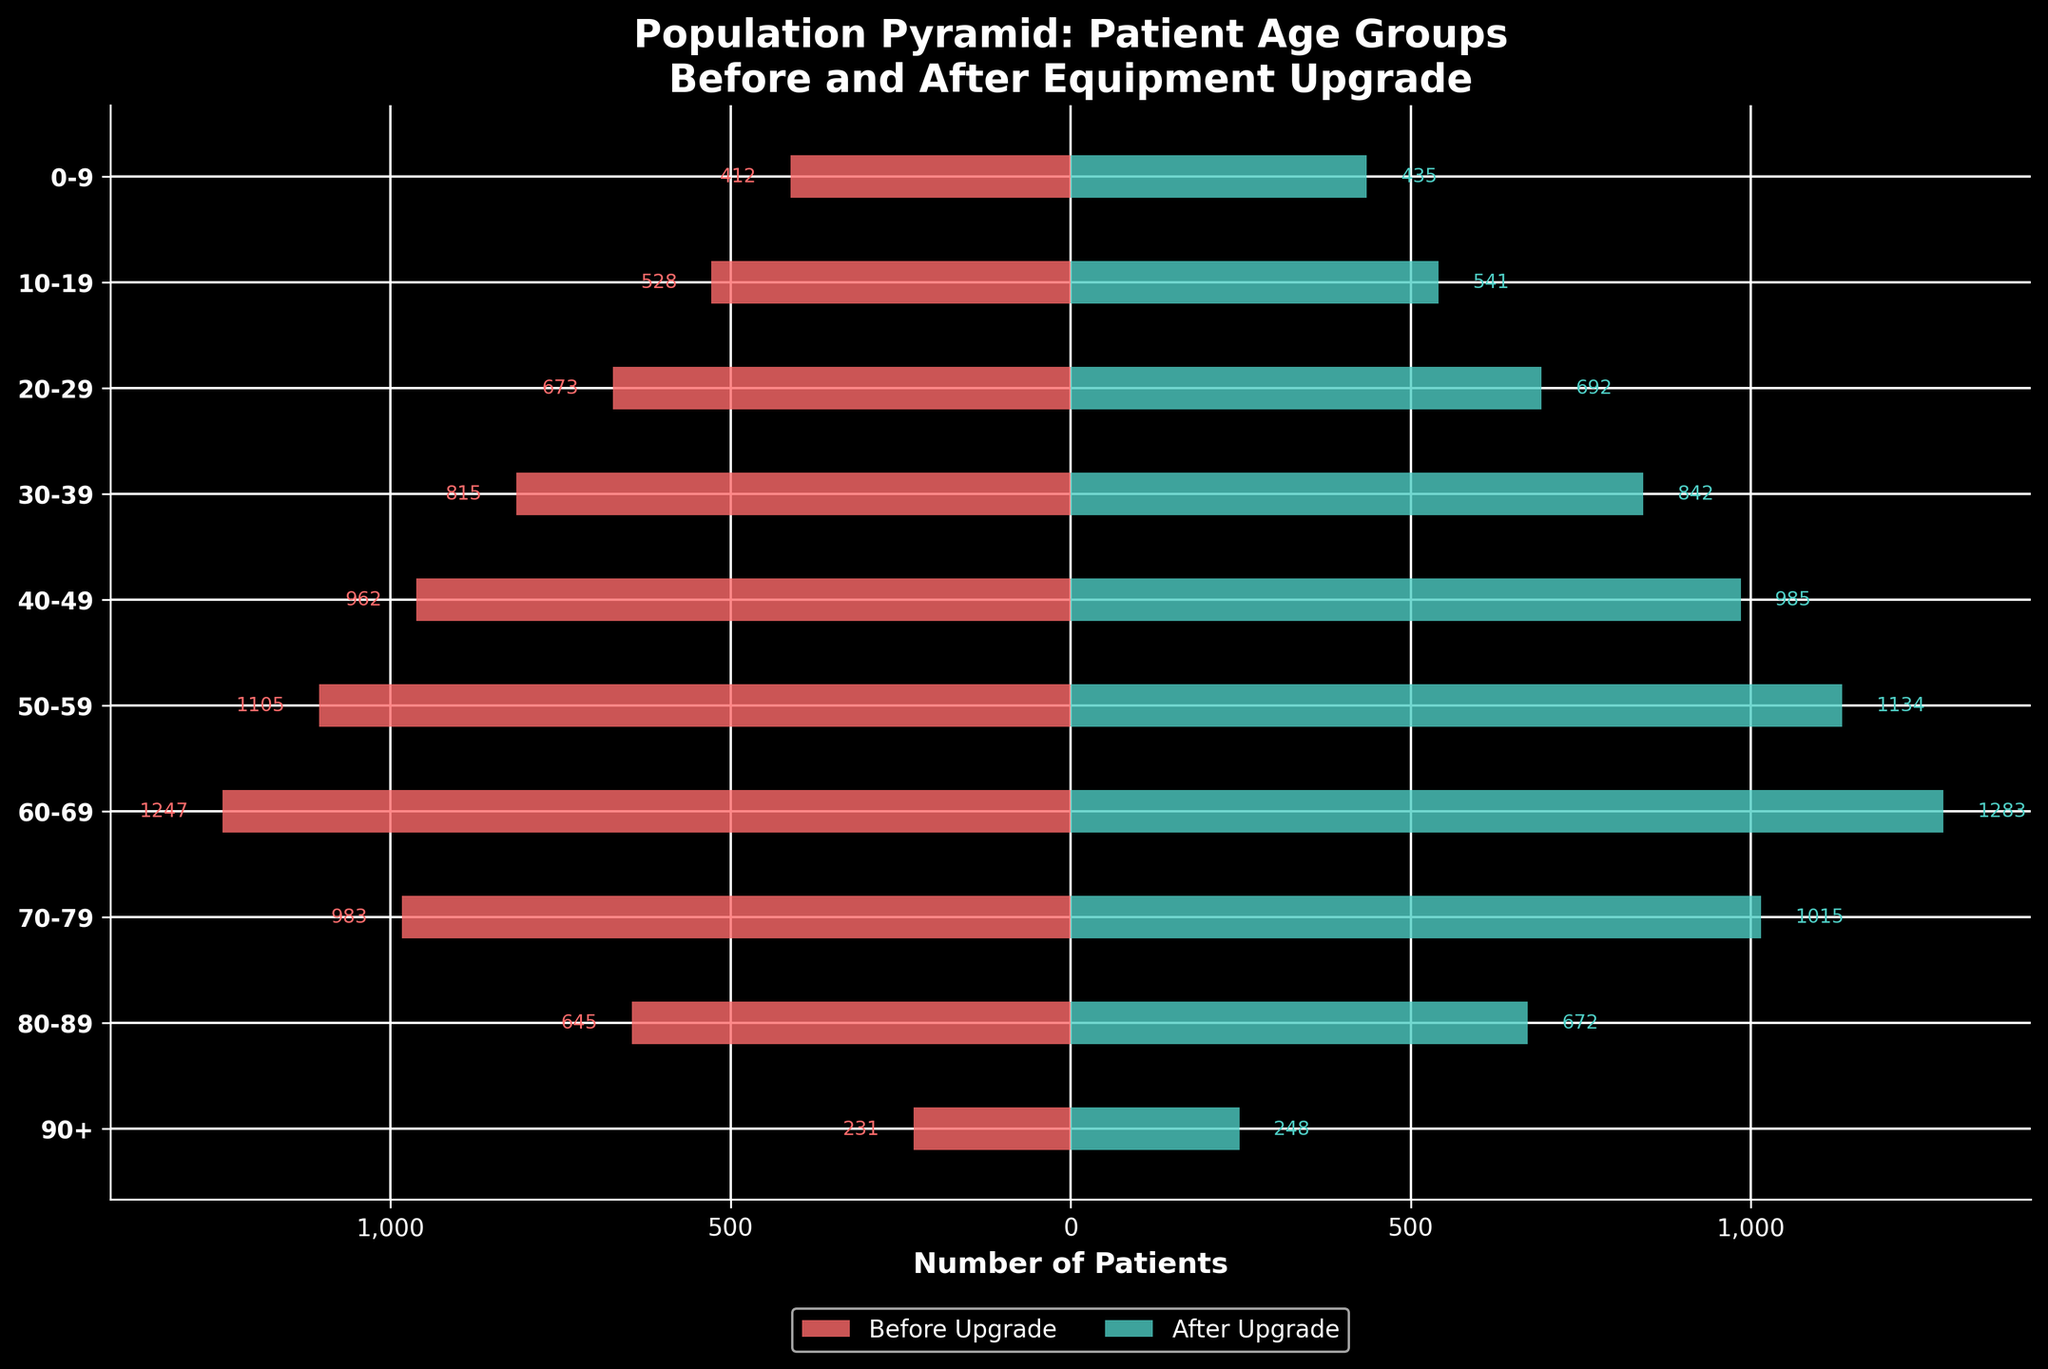What is the title of the figure? The title of the figure is usually shown at the top and provides a brief summary of what the figure represents.
Answer: Population Pyramid: Patient Age Groups Before and After Equipment Upgrade What are the age groups represented on the y-axis? The y-axis shows different age groups which are labeled clearly. Observing these age groups helps in understanding the distribution of patients.
Answer: 0-9, 10-19, 20-29, 30-39, 40-49, 50-59, 60-69, 70-79, 80-89, 90+ Which age group saw the largest increase in the number of patients after the upgrade? By comparing the number of patients before and after the upgrade for each age group, the one with the highest difference represents the largest increase. From the figure, each group's values can be compared visually.
Answer: 60-69 What is the number of patients in the age group 50-59 before and after the upgrade? The figure shows two bars representing the patient numbers before and after the upgrade for each age group, with the exact values labeled on the horizontal bars.
Answer: Before: 1105, After: 1134 How many more patients are there in the 90+ age group after the upgrade compared to before? This involves finding the difference between the number of patients after and before the upgrade for the 90+ age group. From the figure, we read the values and perform the subtraction.
Answer: 248 - 231 = 17 Which age group had the smallest percentage change in patient numbers after the upgrade? To find this, the percentage change for each age group is calculated by (After - Before) / Before * 100. Comparing these values will reveal the smallest percentage change.
Answer: 0-9 How do the patient numbers in the 40-49 age group compare before and after the upgrade? Looking at the lengths and values of the bars corresponding to the 40-49 age group gives a direct comparison of the patient numbers.
Answer: Before: 962, After: 985 What is the total number of patients after the upgrade across all age groups? Summing the patient numbers for all age groups after the upgrade gives the total number of patients. This requires reading the individual values and adding them together.
Answer: 435 + 541 + 692 + 842 + 985 + 1134 + 1283 + 1015 + 672 + 248 = 7847 In which age group is the difference between the number of patients before and after the upgrade the smallest? We need to calculate the difference between patient numbers before and after the upgrade for each age group and find the smallest value among these differences.
Answer: 0-9 Are there any age groups where the number of patients decreased after the upgrade? Observing the lengths and values of the bars before and after the upgrade can determine if any age group's patient values are higher before the upgrade.
Answer: No 